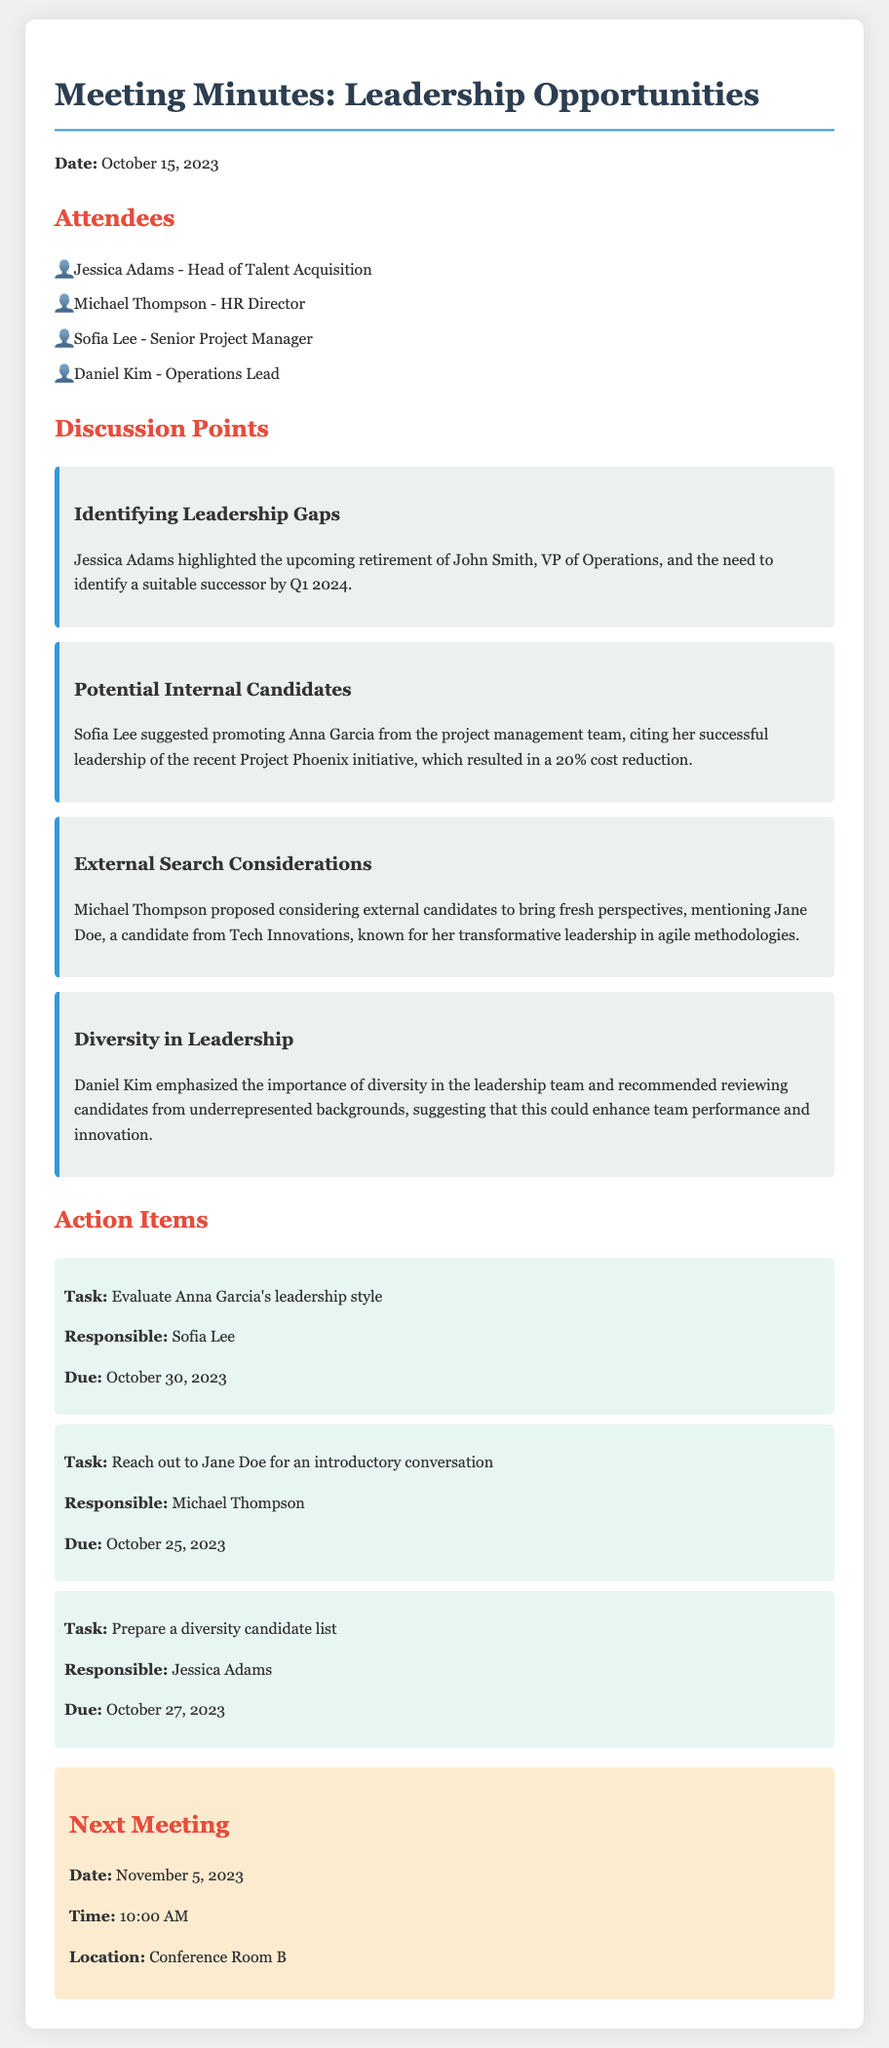What is the date of the meeting? The date of the meeting is specified at the beginning of the document.
Answer: October 15, 2023 Who is the Head of Talent Acquisition? The attendees list provides the names and titles of those present.
Answer: Jessica Adams What action item is assigned to Sofia Lee? The action items section lists tasks along with responsible individuals.
Answer: Evaluate Anna Garcia's leadership style What percentage cost reduction did Project Phoenix achieve? The discussion points provide specific results from Anna Garcia's leadership on Project Phoenix.
Answer: 20% Who proposed considering external candidates? The document mentions who suggested the idea of looking for external candidates.
Answer: Michael Thompson What is the due date for reaching out to Jane Doe? The action items specify due dates for each task.
Answer: October 25, 2023 What is emphasized as important by Daniel Kim? The discussion point highlights key suggestions made by different attendees.
Answer: Diversity in leadership When is the next meeting scheduled? The next meeting details are provided at the end of the document.
Answer: November 5, 2023 